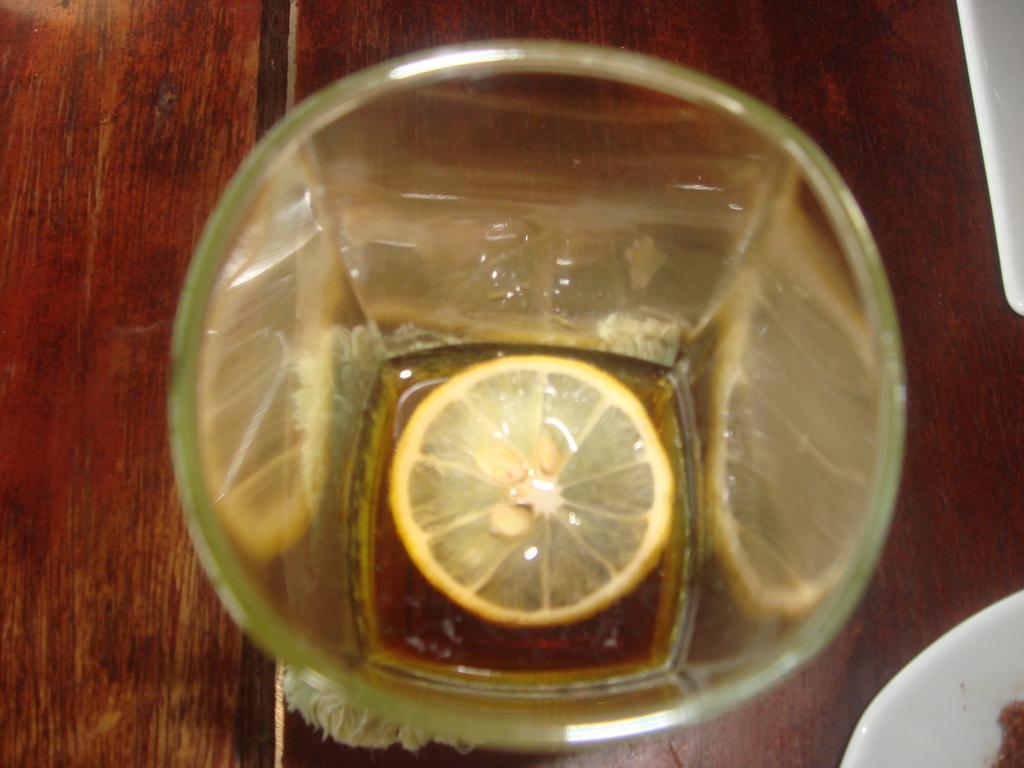Please provide a concise description of this image. In this picture I can observe lemon placed in the glass. The glass is on the wooden surface. 